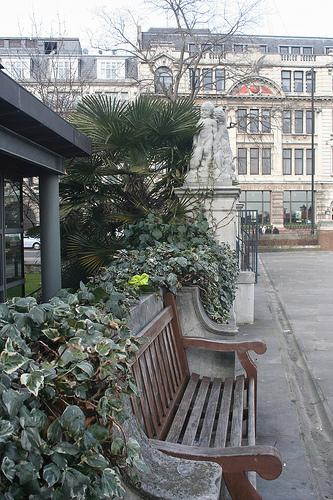Mention the location of a palm plant and something that is beside it. The palm plant is by a bench, and there is a large section of green ivy near them. Create a question related to the image for a multi-choice VQA task, and provide an appropriate answer. What type of plant is located next to the bench? A) Fern B) Ivy C) Palm D) Oak Pick one of the objects in the image and provide a concise description in the context of a visual entailment task. A dark brown wooden bench with a width of 182 and a height of 182 is placed in the image, and it visually entails a sitting area. Identify the object(s) in the image that could serve as a focal point for a referential expression grounding task. The worn brown bench and the palm plant by it could serve as a focal point for a referential expression grounding task. Provide a brief description of the scene depicted in the image. The image features various elements such as glass windows on a beige building, a worn brown wooden bench, a palm plant, and metal fencing among others in an outdoor urban setting. In a brief sentence, describe the overall atmosphere or vibe of the image. The image shows a tranquil city scene with various objects and plants, creating a sense of harmony amongst different elements. Identify the color and a distinctive feature of a bench in the image. There is a worn brown bench with a dark appearance and ragged edges. Choose a task from the given list, and describe how the image supports it. (ex. product advertisement task) For a product advertisement task, the image offers a peaceful outdoor setting that can be used to showcase products like outdoor furniture, plants, or decorative items to create a relaxing environment. Imagine an advertisement featuring this image, what could be the tagline or slogan? "Find your oasis in the city - discover a peaceful urban setting for relaxation and connection." Describe the position and appearance of a grey concrete sidewalk in the image. The grey concrete sidewalk is located by the bench, and it has a rectangular shape with a width of 55 and a height of 55. 